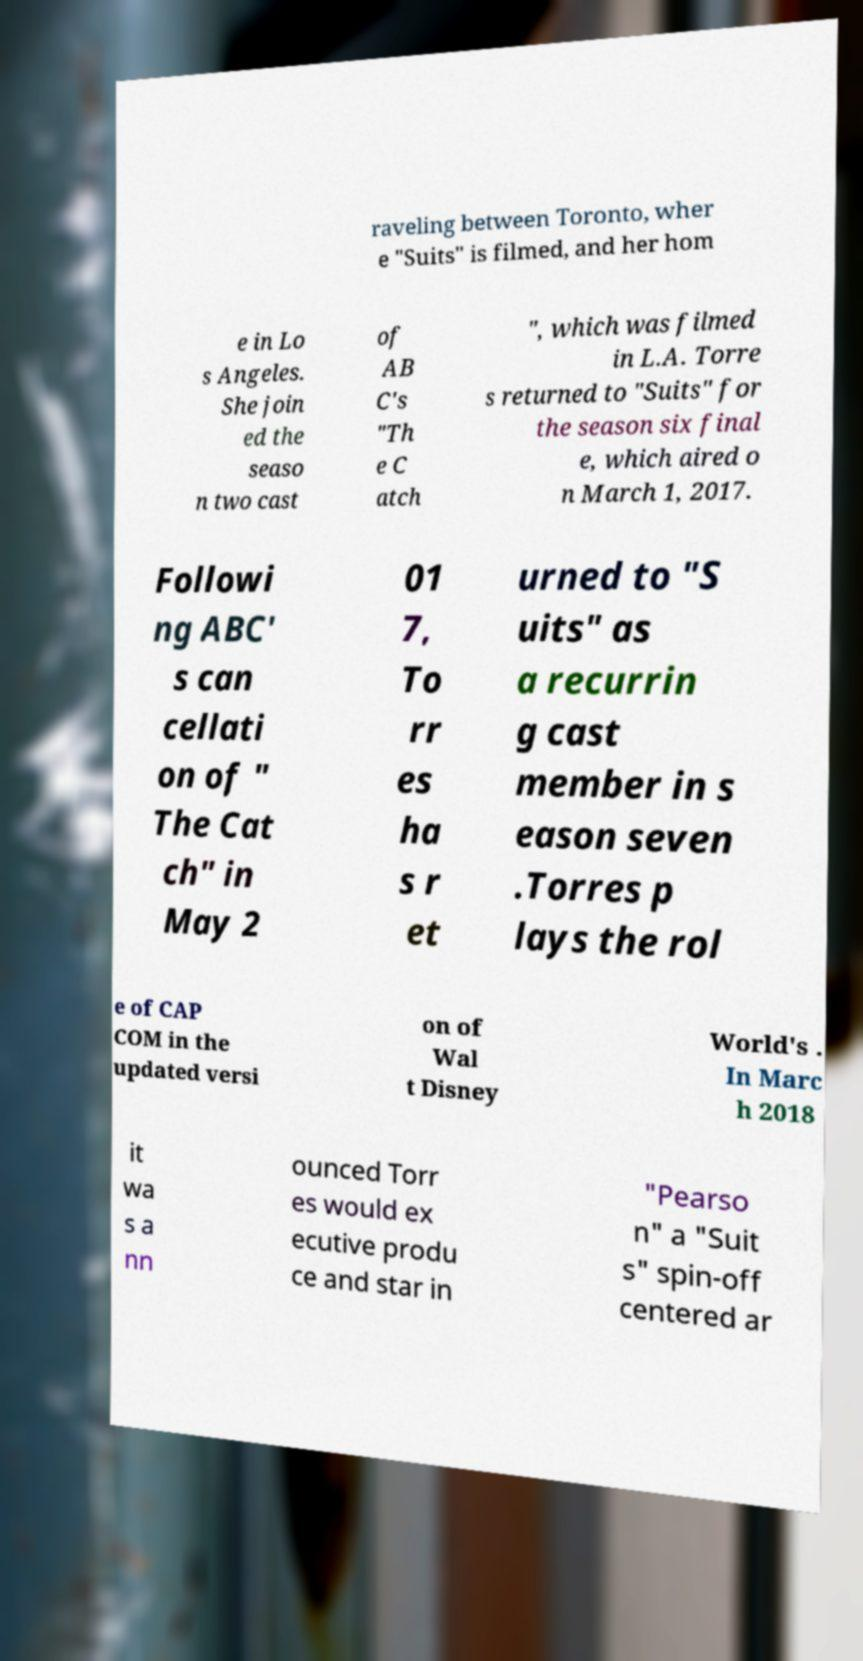There's text embedded in this image that I need extracted. Can you transcribe it verbatim? raveling between Toronto, wher e "Suits" is filmed, and her hom e in Lo s Angeles. She join ed the seaso n two cast of AB C's "Th e C atch ", which was filmed in L.A. Torre s returned to "Suits" for the season six final e, which aired o n March 1, 2017. Followi ng ABC' s can cellati on of " The Cat ch" in May 2 01 7, To rr es ha s r et urned to "S uits" as a recurrin g cast member in s eason seven .Torres p lays the rol e of CAP COM in the updated versi on of Wal t Disney World's . In Marc h 2018 it wa s a nn ounced Torr es would ex ecutive produ ce and star in "Pearso n" a "Suit s" spin-off centered ar 